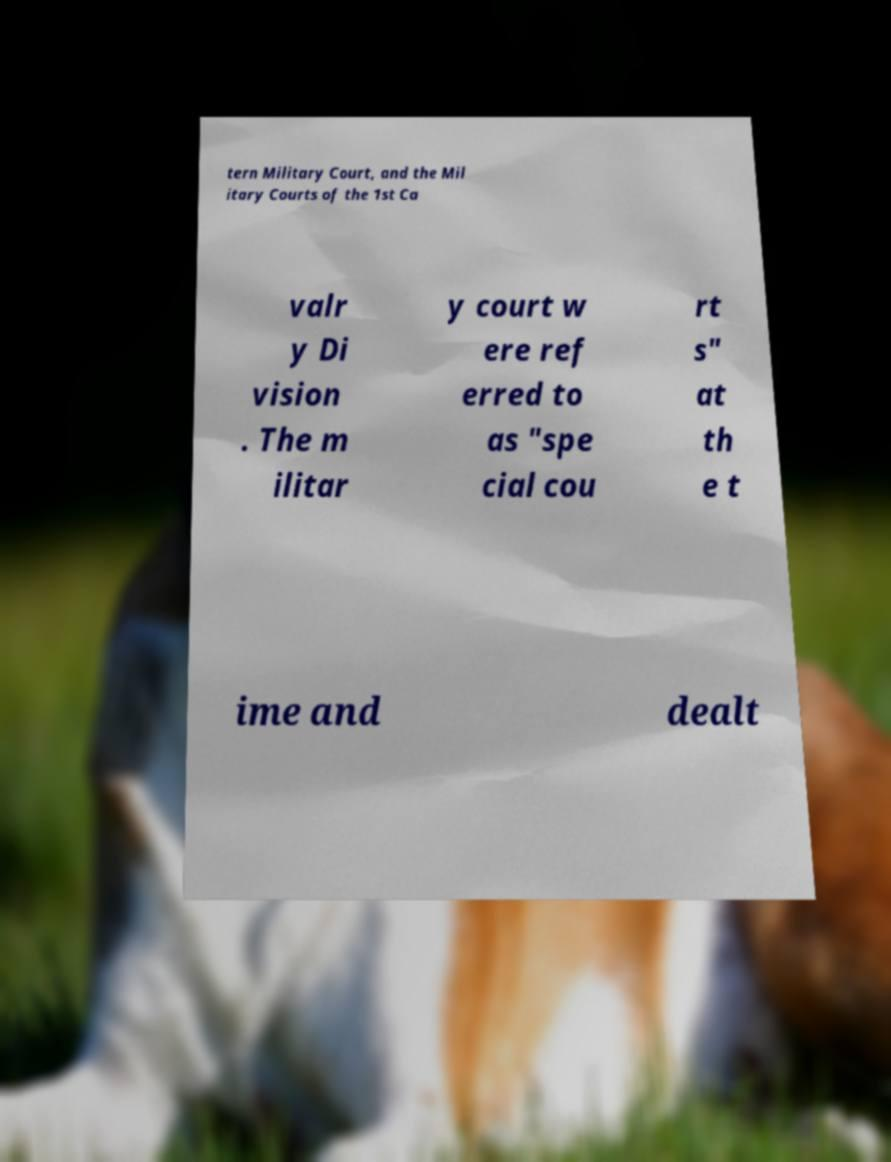What messages or text are displayed in this image? I need them in a readable, typed format. tern Military Court, and the Mil itary Courts of the 1st Ca valr y Di vision . The m ilitar y court w ere ref erred to as "spe cial cou rt s" at th e t ime and dealt 